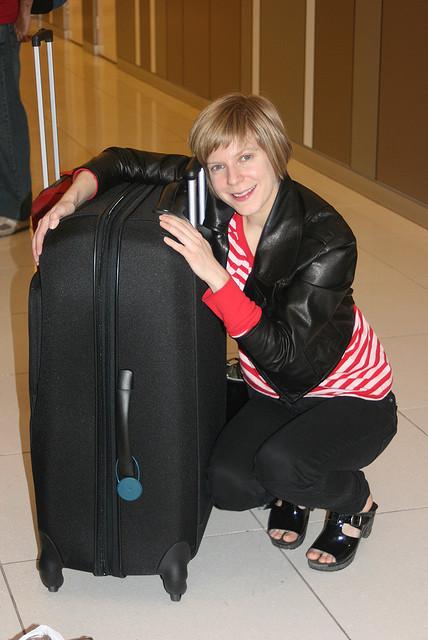What is this person holding?
Answer briefly. Suitcase. How many suitcases do you see?
Short answer required. 1. What is the brand name of the suitcase the lady is touching?
Concise answer only. Samsonite. What color are her shoes?
Concise answer only. Black. 